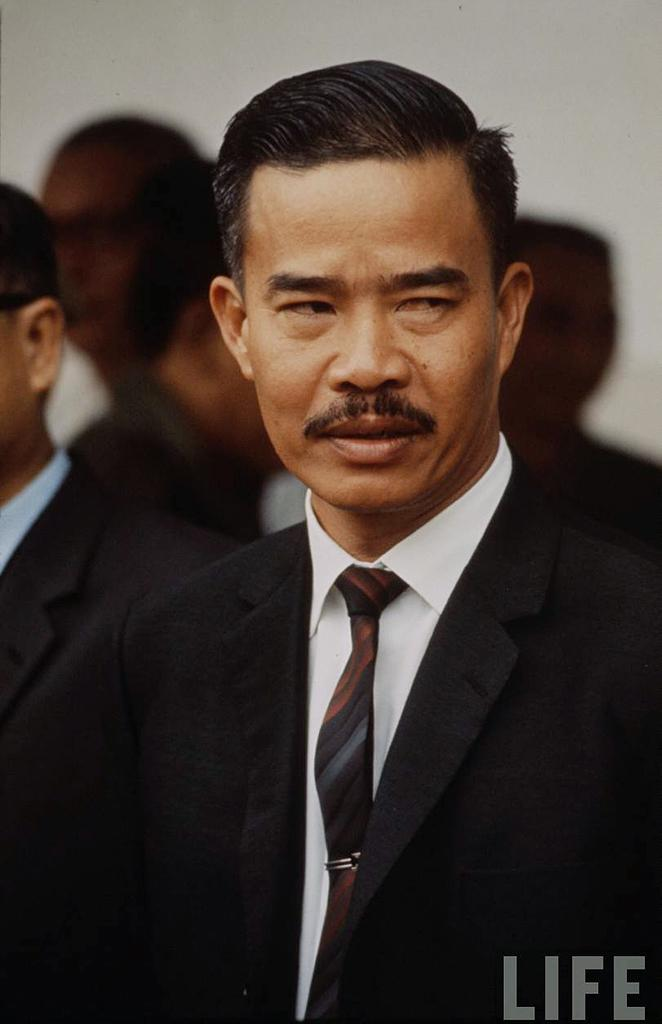What is the man in the image wearing? The man is wearing a black suit in the image. What is the man's posture in the image? The man is standing in the image. What can be seen in the background of the image? There is a group of people in the background of the image. Where is the text located in the image? The text is at the bottom right corner of the image. What type of vegetable is the man holding in the image? There is no vegetable present in the image; the man is wearing a black suit and standing. 